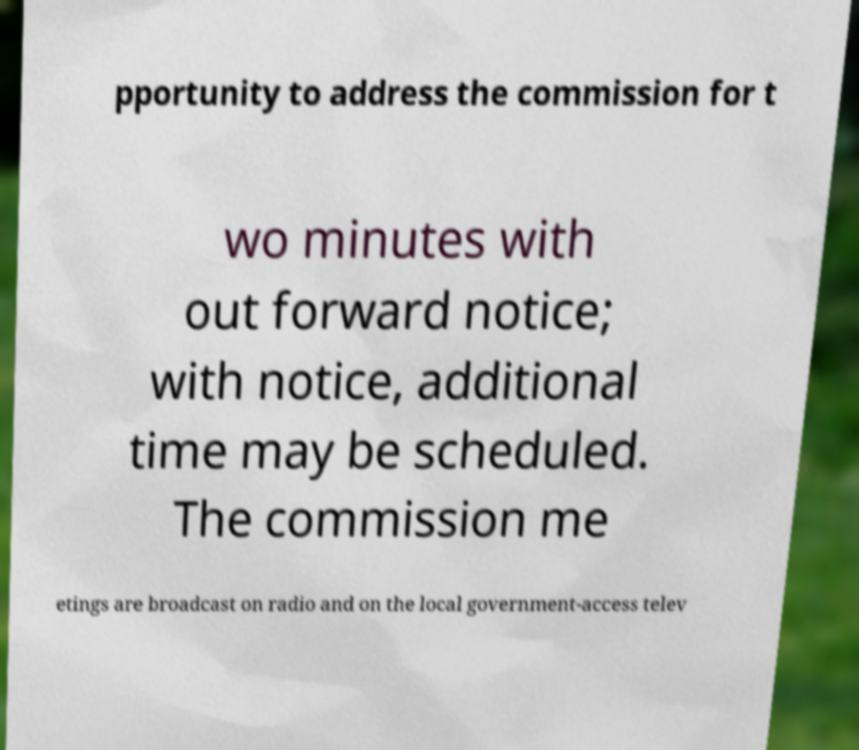Could you extract and type out the text from this image? pportunity to address the commission for t wo minutes with out forward notice; with notice, additional time may be scheduled. The commission me etings are broadcast on radio and on the local government-access telev 